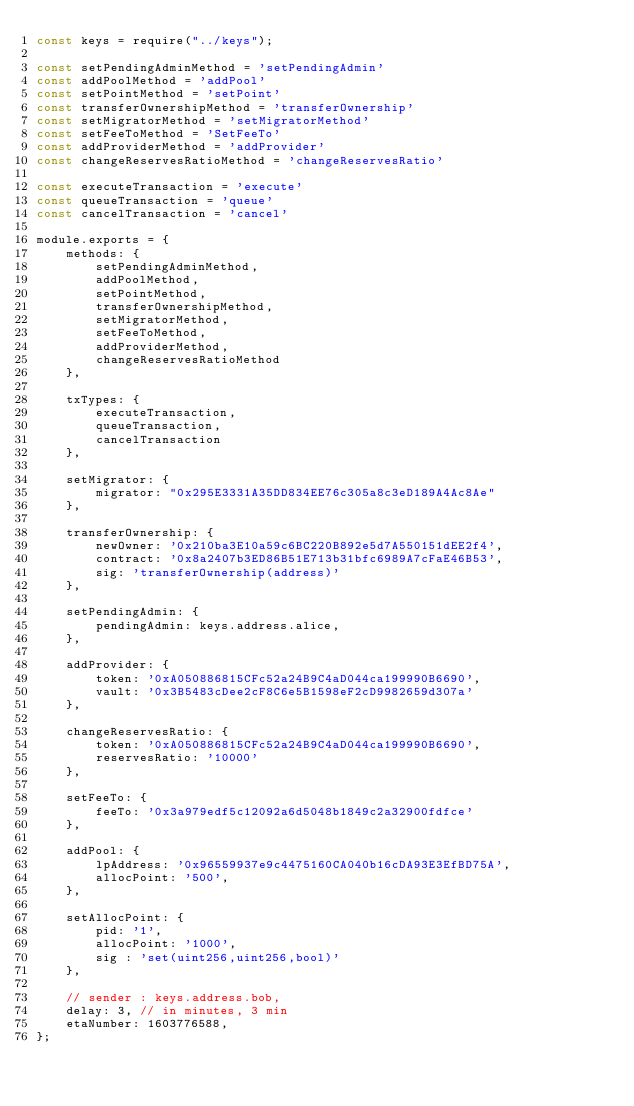Convert code to text. <code><loc_0><loc_0><loc_500><loc_500><_JavaScript_>const keys = require("../keys");

const setPendingAdminMethod = 'setPendingAdmin'
const addPoolMethod = 'addPool'
const setPointMethod = 'setPoint'
const transferOwnershipMethod = 'transferOwnership'
const setMigratorMethod = 'setMigratorMethod'
const setFeeToMethod = 'SetFeeTo'
const addProviderMethod = 'addProvider'
const changeReservesRatioMethod = 'changeReservesRatio'

const executeTransaction = 'execute'
const queueTransaction = 'queue'
const cancelTransaction = 'cancel'

module.exports = {
    methods: {
        setPendingAdminMethod,
        addPoolMethod,
        setPointMethod,
        transferOwnershipMethod,
        setMigratorMethod,
        setFeeToMethod,
        addProviderMethod,
        changeReservesRatioMethod
    },

    txTypes: {
        executeTransaction,
        queueTransaction,
        cancelTransaction
    },

    setMigrator: {
        migrator: "0x295E3331A35DD834EE76c305a8c3eD189A4Ac8Ae"
    },

    transferOwnership: {
        newOwner: '0x210ba3E10a59c6BC220B892e5d7A550151dEE2f4',
        contract: '0x8a2407b3ED86B51E713b31bfc6989A7cFaE46B53',
        sig: 'transferOwnership(address)'
    },

    setPendingAdmin: {
        pendingAdmin: keys.address.alice,
    },

    addProvider: {
        token: '0xA050886815CFc52a24B9C4aD044ca199990B6690',
        vault: '0x3B5483cDee2cF8C6e5B1598eF2cD9982659d307a'
    },

    changeReservesRatio: {
        token: '0xA050886815CFc52a24B9C4aD044ca199990B6690',
        reservesRatio: '10000'
    },

    setFeeTo: {
        feeTo: '0x3a979edf5c12092a6d5048b1849c2a32900fdfce'
    },

    addPool: {
        lpAddress: '0x96559937e9c4475160CA040b16cDA93E3EfBD75A',
        allocPoint: '500',
    },

    setAllocPoint: {
        pid: '1',
        allocPoint: '1000',
        sig : 'set(uint256,uint256,bool)'
    },

    // sender : keys.address.bob,
    delay: 3, // in minutes, 3 min
    etaNumber: 1603776588,
};</code> 